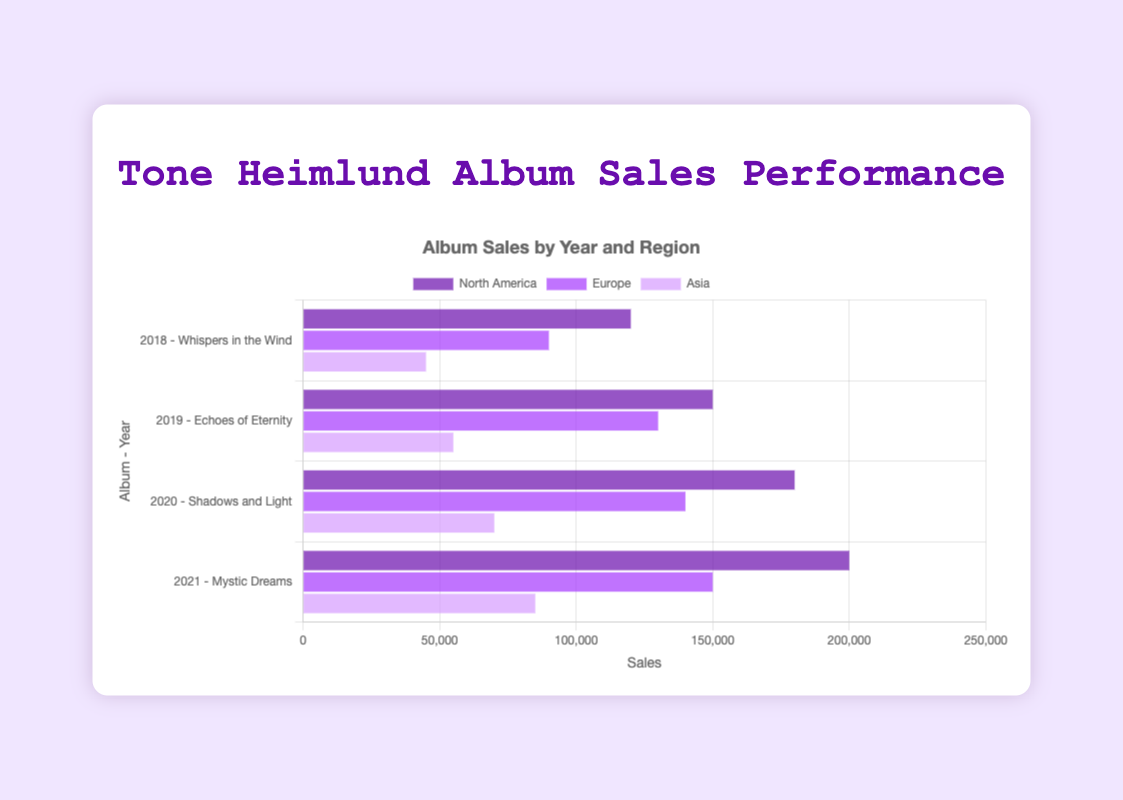What was the total sales of "Mystic Dreams" in 2021 across all regions? Sum the sales of "Mystic Dreams" in North America (200,000), Europe (150,000), and Asia (85,000): 200,000 + 150,000 + 85,000 = 435,000
Answer: 435,000 Which region had the highest sales for the album "Echoes of Eternity" in 2019? Compare the sales of "Echoes of Eternity" in North America (150,000), Europe (130,000), and Asia (55,000). North America had the highest sales.
Answer: North America Which album had the lowest sales in Asia, and what were the sales? Compare the sales in Asia for all albums: "Whispers in the Wind" (45,000), "Echoes of Eternity" (55,000), "Shadows and Light" (70,000), and "Mystic Dreams" (85,000). "Whispers in the Wind" had the lowest sales with 45,000.
Answer: Whispers in the Wind, 45,000 What was the increase in sales in Europe from "Whispers in the Wind" (2018) to "Echoes of Eternity" (2019)? Subtract the sales of "Whispers in the Wind" in Europe (90,000) from the sales of "Echoes of Eternity" in Europe (130,000): 130,000 - 90,000 = 40,000
Answer: 40,000 In 2020, by how much did the sales of "Shadows and Light" in North America exceed the sales in Asia? Subtract the sales in Asia (70,000) from the sales in North America (180,000): 180,000 - 70,000 = 110,000
Answer: 110,000 How did the total sales in North America change from 2019 to 2020? Subtract the sales in North America in 2019 (150,000) from the sales in 2020 (180,000): 180,000 - 150,000 = 30,000
Answer: 30,000 What is the average sales of the album "Shadows and Light" across all regions in 2020? Sum the sales of "Shadows and Light" in North America (180,000), Europe (140,000), and Asia (70,000), then divide by 3: (180,000 + 140,000 + 70,000) / 3 = 390,000 / 3 = 130,000
Answer: 130,000 Which album had the highest sales in Europe? Compare the sales in Europe for all albums: "Whispers in the Wind" (90,000), "Echoes of Eternity" (130,000), "Shadows and Light" (140,000), and "Mystic Dreams" (150,000). "Mystic Dreams" had the highest sales.
Answer: Mystic Dreams What was the difference in total sales between Asia and Europe for the album "Whispers in the Wind" in 2018? Subtract the sales in Asia (45,000) from the sales in Europe (90,000): 90,000 - 45,000 = 45,000
Answer: 45,000 